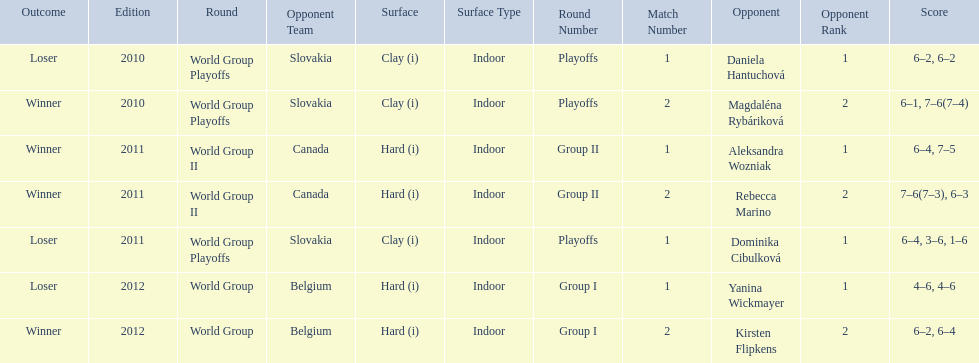Number of games in the match against dominika cibulkova? 3. 